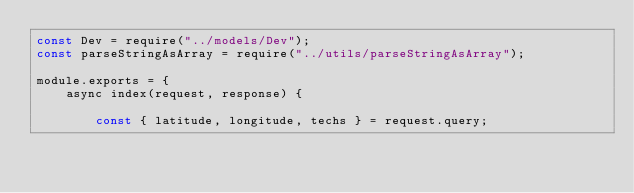Convert code to text. <code><loc_0><loc_0><loc_500><loc_500><_JavaScript_>const Dev = require("../models/Dev");
const parseStringAsArray = require("../utils/parseStringAsArray");

module.exports = {
    async index(request, response) {

        const { latitude, longitude, techs } = request.query;</code> 